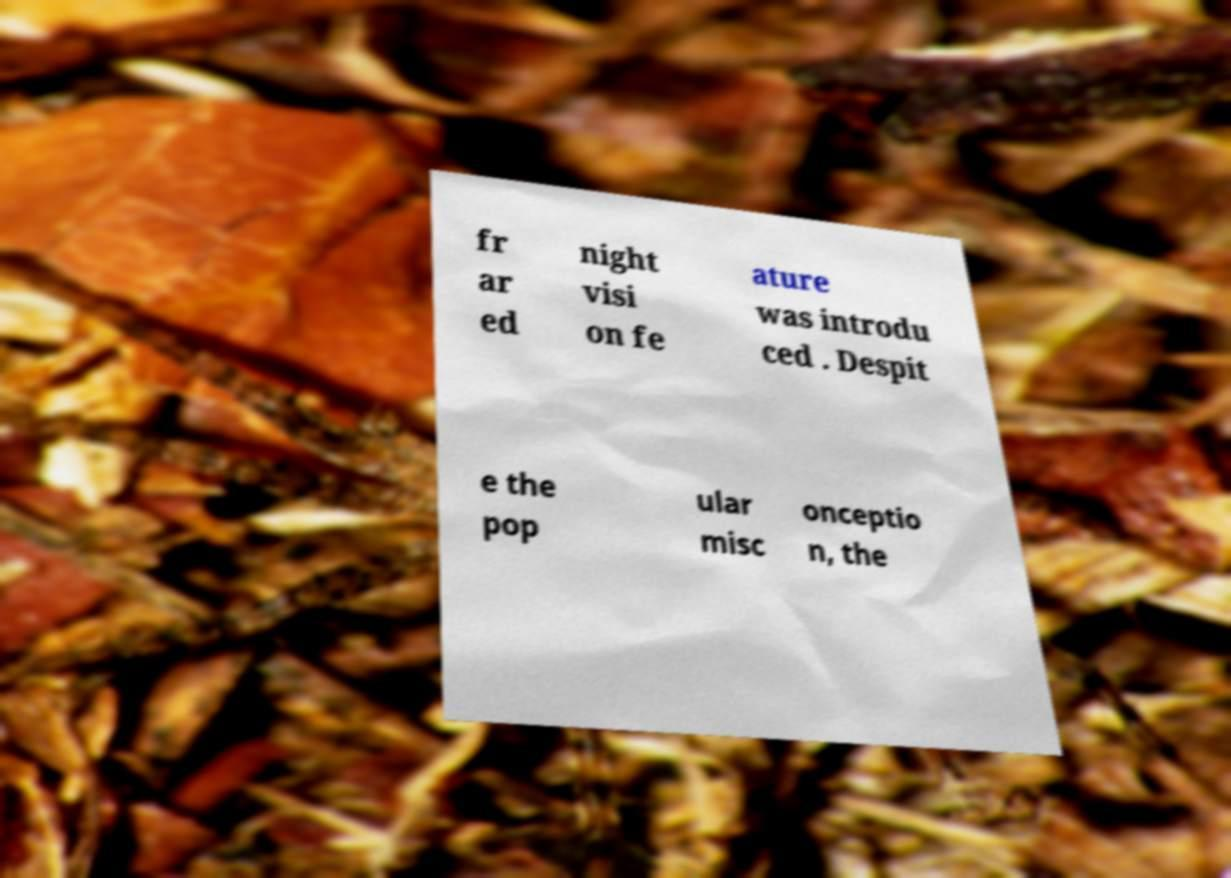Can you accurately transcribe the text from the provided image for me? fr ar ed night visi on fe ature was introdu ced . Despit e the pop ular misc onceptio n, the 